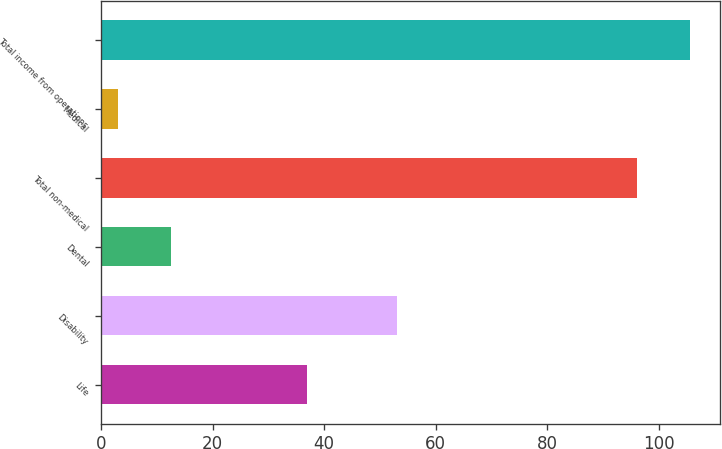Convert chart. <chart><loc_0><loc_0><loc_500><loc_500><bar_chart><fcel>Life<fcel>Disability<fcel>Dental<fcel>Total non-medical<fcel>Medical<fcel>Total income from operations<nl><fcel>37<fcel>53<fcel>12.6<fcel>96<fcel>3<fcel>105.6<nl></chart> 